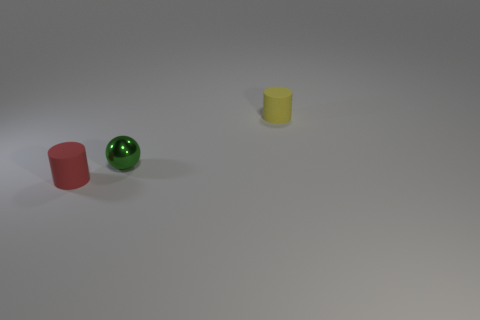Add 3 shiny spheres. How many objects exist? 6 Subtract all cylinders. How many objects are left? 1 Add 2 small metallic spheres. How many small metallic spheres exist? 3 Subtract 0 purple cylinders. How many objects are left? 3 Subtract all green balls. Subtract all tiny blue metallic cylinders. How many objects are left? 2 Add 3 red objects. How many red objects are left? 4 